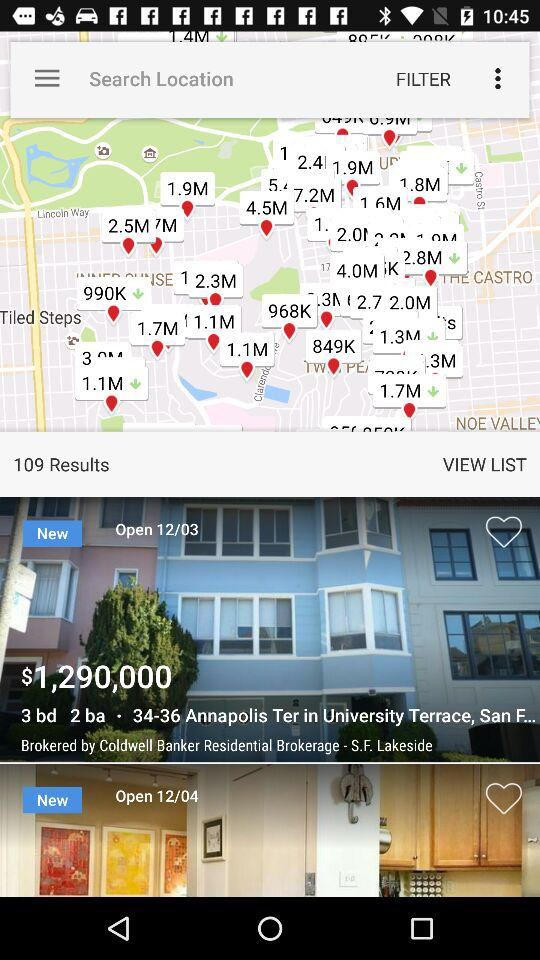How many prices are shown?
When the provided information is insufficient, respond with <no answer>. <no answer> 